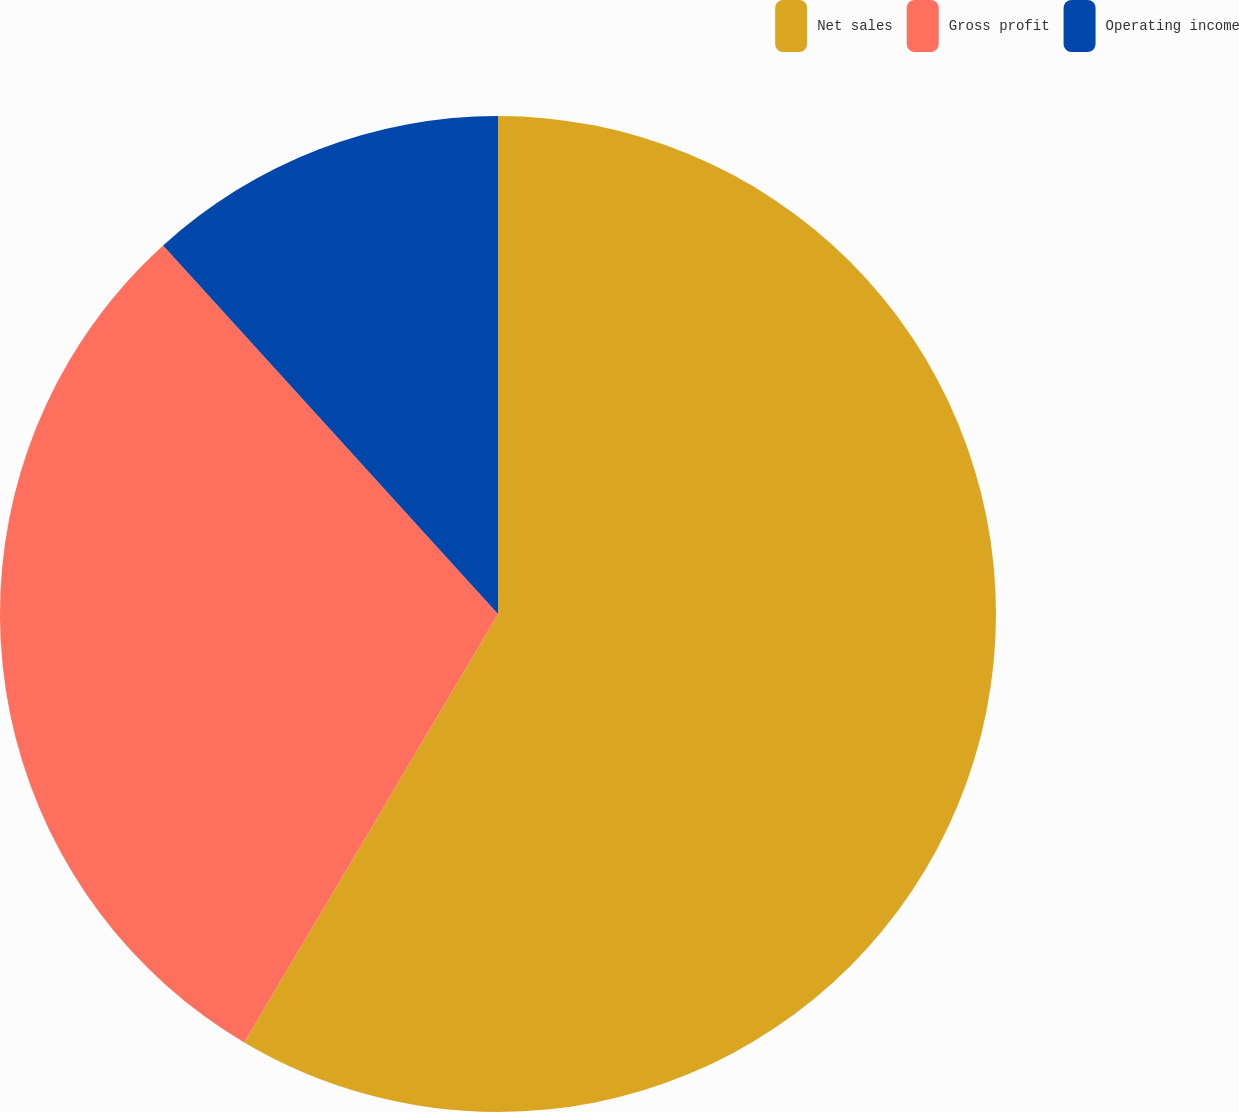<chart> <loc_0><loc_0><loc_500><loc_500><pie_chart><fcel>Net sales<fcel>Gross profit<fcel>Operating income<nl><fcel>58.51%<fcel>29.75%<fcel>11.74%<nl></chart> 